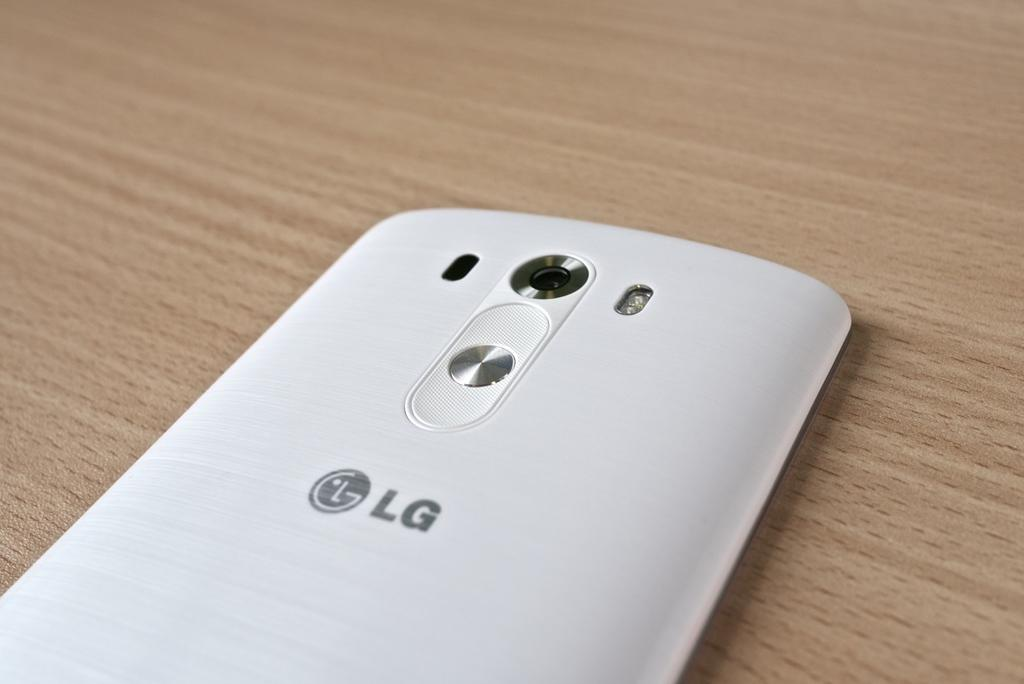Provide a one-sentence caption for the provided image. The back of a phone made by the brand LG in white. 